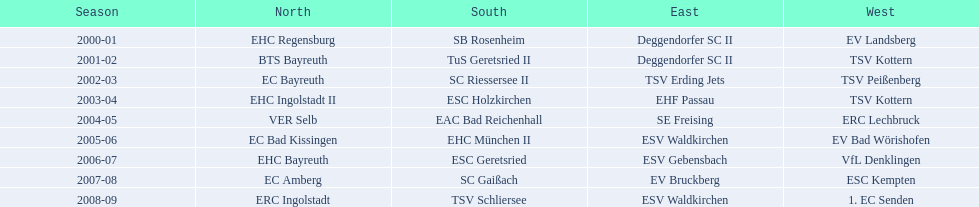Which teams were victorious in the north during their specific years? 2000-01, EHC Regensburg, BTS Bayreuth, EC Bayreuth, EHC Ingolstadt II, VER Selb, EC Bad Kissingen, EHC Bayreuth, EC Amberg, ERC Ingolstadt. Which team triumphed only in the 2000-01 season? EHC Regensburg. 